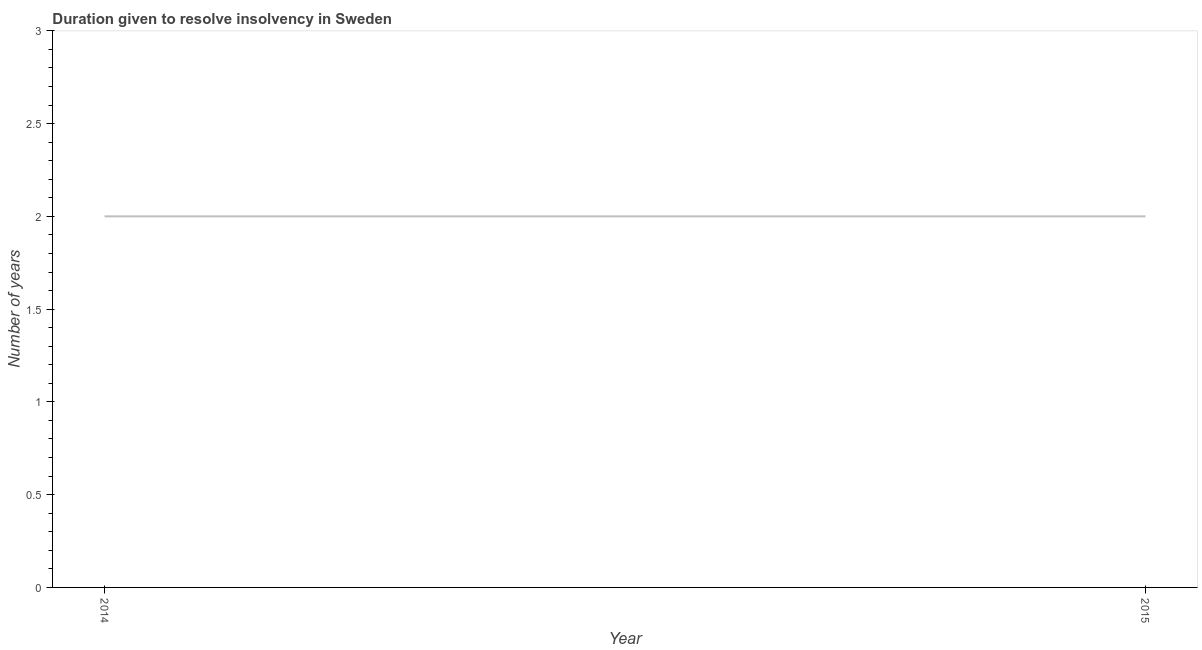What is the number of years to resolve insolvency in 2014?
Give a very brief answer. 2. Across all years, what is the maximum number of years to resolve insolvency?
Give a very brief answer. 2. Across all years, what is the minimum number of years to resolve insolvency?
Your answer should be very brief. 2. In which year was the number of years to resolve insolvency maximum?
Provide a short and direct response. 2014. What is the sum of the number of years to resolve insolvency?
Your response must be concise. 4. What is the difference between the number of years to resolve insolvency in 2014 and 2015?
Provide a short and direct response. 0. What is the average number of years to resolve insolvency per year?
Make the answer very short. 2. What is the median number of years to resolve insolvency?
Keep it short and to the point. 2. What is the ratio of the number of years to resolve insolvency in 2014 to that in 2015?
Give a very brief answer. 1. Does the graph contain any zero values?
Your answer should be compact. No. Does the graph contain grids?
Keep it short and to the point. No. What is the title of the graph?
Your response must be concise. Duration given to resolve insolvency in Sweden. What is the label or title of the Y-axis?
Your answer should be compact. Number of years. What is the Number of years of 2015?
Your answer should be compact. 2. What is the difference between the Number of years in 2014 and 2015?
Ensure brevity in your answer.  0. 